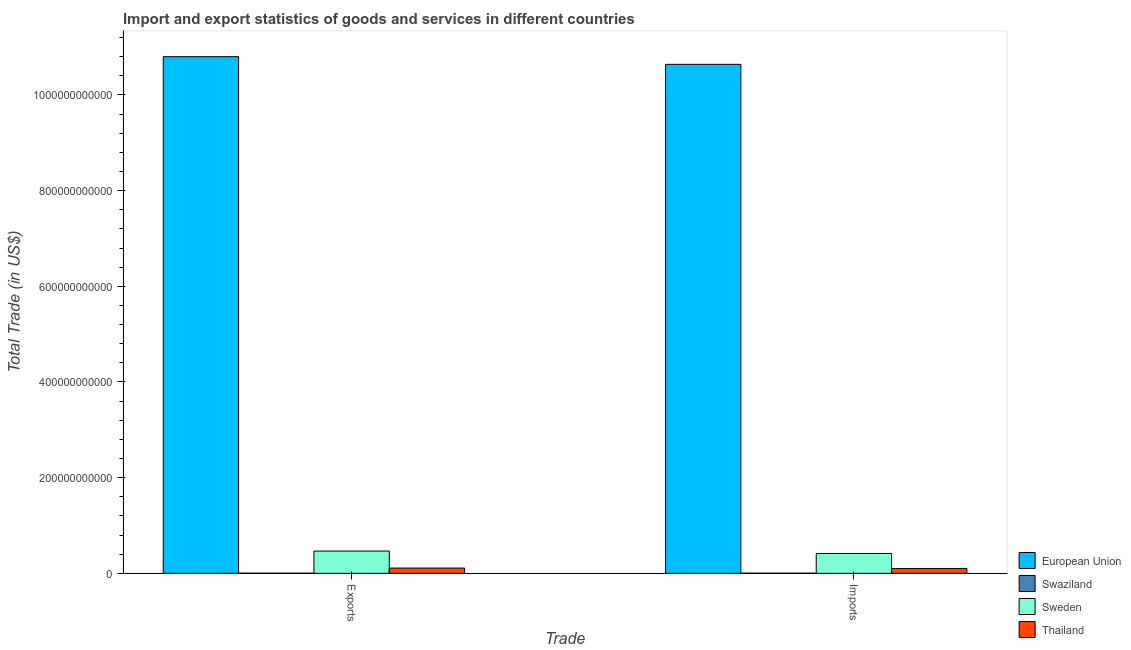Are the number of bars per tick equal to the number of legend labels?
Keep it short and to the point. Yes. Are the number of bars on each tick of the X-axis equal?
Provide a succinct answer. Yes. How many bars are there on the 1st tick from the left?
Your answer should be very brief. 4. What is the label of the 1st group of bars from the left?
Your response must be concise. Exports. What is the imports of goods and services in Swaziland?
Give a very brief answer. 3.58e+08. Across all countries, what is the maximum export of goods and services?
Offer a terse response. 1.08e+12. Across all countries, what is the minimum export of goods and services?
Make the answer very short. 3.09e+08. In which country was the imports of goods and services maximum?
Your answer should be compact. European Union. In which country was the imports of goods and services minimum?
Keep it short and to the point. Swaziland. What is the total imports of goods and services in the graph?
Give a very brief answer. 1.12e+12. What is the difference between the export of goods and services in Sweden and that in European Union?
Provide a succinct answer. -1.03e+12. What is the difference between the export of goods and services in Sweden and the imports of goods and services in Thailand?
Give a very brief answer. 3.64e+1. What is the average export of goods and services per country?
Make the answer very short. 2.84e+11. What is the difference between the export of goods and services and imports of goods and services in Sweden?
Provide a succinct answer. 5.05e+09. In how many countries, is the imports of goods and services greater than 80000000000 US$?
Keep it short and to the point. 1. What is the ratio of the export of goods and services in Swaziland to that in Thailand?
Your answer should be compact. 0.03. What does the 2nd bar from the left in Exports represents?
Offer a very short reply. Swaziland. What does the 2nd bar from the right in Exports represents?
Your answer should be compact. Sweden. Are all the bars in the graph horizontal?
Make the answer very short. No. What is the difference between two consecutive major ticks on the Y-axis?
Provide a succinct answer. 2.00e+11. Are the values on the major ticks of Y-axis written in scientific E-notation?
Offer a very short reply. No. How many legend labels are there?
Ensure brevity in your answer.  4. How are the legend labels stacked?
Keep it short and to the point. Vertical. What is the title of the graph?
Provide a succinct answer. Import and export statistics of goods and services in different countries. What is the label or title of the X-axis?
Provide a succinct answer. Trade. What is the label or title of the Y-axis?
Make the answer very short. Total Trade (in US$). What is the Total Trade (in US$) of European Union in Exports?
Provide a short and direct response. 1.08e+12. What is the Total Trade (in US$) of Swaziland in Exports?
Provide a succinct answer. 3.09e+08. What is the Total Trade (in US$) of Sweden in Exports?
Your answer should be very brief. 4.65e+1. What is the Total Trade (in US$) of Thailand in Exports?
Provide a succinct answer. 1.10e+1. What is the Total Trade (in US$) in European Union in Imports?
Provide a short and direct response. 1.06e+12. What is the Total Trade (in US$) in Swaziland in Imports?
Keep it short and to the point. 3.58e+08. What is the Total Trade (in US$) in Sweden in Imports?
Give a very brief answer. 4.15e+1. What is the Total Trade (in US$) of Thailand in Imports?
Ensure brevity in your answer.  1.02e+1. Across all Trade, what is the maximum Total Trade (in US$) in European Union?
Your answer should be very brief. 1.08e+12. Across all Trade, what is the maximum Total Trade (in US$) of Swaziland?
Offer a very short reply. 3.58e+08. Across all Trade, what is the maximum Total Trade (in US$) in Sweden?
Your response must be concise. 4.65e+1. Across all Trade, what is the maximum Total Trade (in US$) of Thailand?
Your answer should be compact. 1.10e+1. Across all Trade, what is the minimum Total Trade (in US$) of European Union?
Offer a terse response. 1.06e+12. Across all Trade, what is the minimum Total Trade (in US$) in Swaziland?
Offer a very short reply. 3.09e+08. Across all Trade, what is the minimum Total Trade (in US$) in Sweden?
Your answer should be very brief. 4.15e+1. Across all Trade, what is the minimum Total Trade (in US$) in Thailand?
Your response must be concise. 1.02e+1. What is the total Total Trade (in US$) of European Union in the graph?
Provide a short and direct response. 2.14e+12. What is the total Total Trade (in US$) of Swaziland in the graph?
Offer a very short reply. 6.67e+08. What is the total Total Trade (in US$) in Sweden in the graph?
Provide a short and direct response. 8.80e+1. What is the total Total Trade (in US$) in Thailand in the graph?
Make the answer very short. 2.12e+1. What is the difference between the Total Trade (in US$) of European Union in Exports and that in Imports?
Make the answer very short. 1.61e+1. What is the difference between the Total Trade (in US$) in Swaziland in Exports and that in Imports?
Keep it short and to the point. -4.94e+07. What is the difference between the Total Trade (in US$) in Sweden in Exports and that in Imports?
Make the answer very short. 5.05e+09. What is the difference between the Total Trade (in US$) in Thailand in Exports and that in Imports?
Your answer should be compact. 8.76e+08. What is the difference between the Total Trade (in US$) of European Union in Exports and the Total Trade (in US$) of Swaziland in Imports?
Give a very brief answer. 1.08e+12. What is the difference between the Total Trade (in US$) in European Union in Exports and the Total Trade (in US$) in Sweden in Imports?
Make the answer very short. 1.04e+12. What is the difference between the Total Trade (in US$) in European Union in Exports and the Total Trade (in US$) in Thailand in Imports?
Offer a very short reply. 1.07e+12. What is the difference between the Total Trade (in US$) of Swaziland in Exports and the Total Trade (in US$) of Sweden in Imports?
Make the answer very short. -4.12e+1. What is the difference between the Total Trade (in US$) of Swaziland in Exports and the Total Trade (in US$) of Thailand in Imports?
Your answer should be very brief. -9.85e+09. What is the difference between the Total Trade (in US$) in Sweden in Exports and the Total Trade (in US$) in Thailand in Imports?
Your answer should be very brief. 3.64e+1. What is the average Total Trade (in US$) of European Union per Trade?
Make the answer very short. 1.07e+12. What is the average Total Trade (in US$) in Swaziland per Trade?
Your answer should be very brief. 3.34e+08. What is the average Total Trade (in US$) in Sweden per Trade?
Offer a terse response. 4.40e+1. What is the average Total Trade (in US$) of Thailand per Trade?
Offer a very short reply. 1.06e+1. What is the difference between the Total Trade (in US$) in European Union and Total Trade (in US$) in Swaziland in Exports?
Your response must be concise. 1.08e+12. What is the difference between the Total Trade (in US$) in European Union and Total Trade (in US$) in Sweden in Exports?
Your answer should be very brief. 1.03e+12. What is the difference between the Total Trade (in US$) of European Union and Total Trade (in US$) of Thailand in Exports?
Your response must be concise. 1.07e+12. What is the difference between the Total Trade (in US$) of Swaziland and Total Trade (in US$) of Sweden in Exports?
Keep it short and to the point. -4.62e+1. What is the difference between the Total Trade (in US$) of Swaziland and Total Trade (in US$) of Thailand in Exports?
Your answer should be very brief. -1.07e+1. What is the difference between the Total Trade (in US$) in Sweden and Total Trade (in US$) in Thailand in Exports?
Your answer should be very brief. 3.55e+1. What is the difference between the Total Trade (in US$) in European Union and Total Trade (in US$) in Swaziland in Imports?
Provide a succinct answer. 1.06e+12. What is the difference between the Total Trade (in US$) in European Union and Total Trade (in US$) in Sweden in Imports?
Give a very brief answer. 1.02e+12. What is the difference between the Total Trade (in US$) of European Union and Total Trade (in US$) of Thailand in Imports?
Your answer should be very brief. 1.05e+12. What is the difference between the Total Trade (in US$) in Swaziland and Total Trade (in US$) in Sweden in Imports?
Keep it short and to the point. -4.11e+1. What is the difference between the Total Trade (in US$) of Swaziland and Total Trade (in US$) of Thailand in Imports?
Offer a terse response. -9.80e+09. What is the difference between the Total Trade (in US$) of Sweden and Total Trade (in US$) of Thailand in Imports?
Offer a terse response. 3.13e+1. What is the ratio of the Total Trade (in US$) in European Union in Exports to that in Imports?
Keep it short and to the point. 1.02. What is the ratio of the Total Trade (in US$) of Swaziland in Exports to that in Imports?
Make the answer very short. 0.86. What is the ratio of the Total Trade (in US$) in Sweden in Exports to that in Imports?
Your response must be concise. 1.12. What is the ratio of the Total Trade (in US$) in Thailand in Exports to that in Imports?
Ensure brevity in your answer.  1.09. What is the difference between the highest and the second highest Total Trade (in US$) of European Union?
Keep it short and to the point. 1.61e+1. What is the difference between the highest and the second highest Total Trade (in US$) in Swaziland?
Make the answer very short. 4.94e+07. What is the difference between the highest and the second highest Total Trade (in US$) of Sweden?
Your answer should be compact. 5.05e+09. What is the difference between the highest and the second highest Total Trade (in US$) in Thailand?
Provide a succinct answer. 8.76e+08. What is the difference between the highest and the lowest Total Trade (in US$) of European Union?
Your response must be concise. 1.61e+1. What is the difference between the highest and the lowest Total Trade (in US$) in Swaziland?
Give a very brief answer. 4.94e+07. What is the difference between the highest and the lowest Total Trade (in US$) of Sweden?
Your answer should be compact. 5.05e+09. What is the difference between the highest and the lowest Total Trade (in US$) in Thailand?
Your answer should be compact. 8.76e+08. 